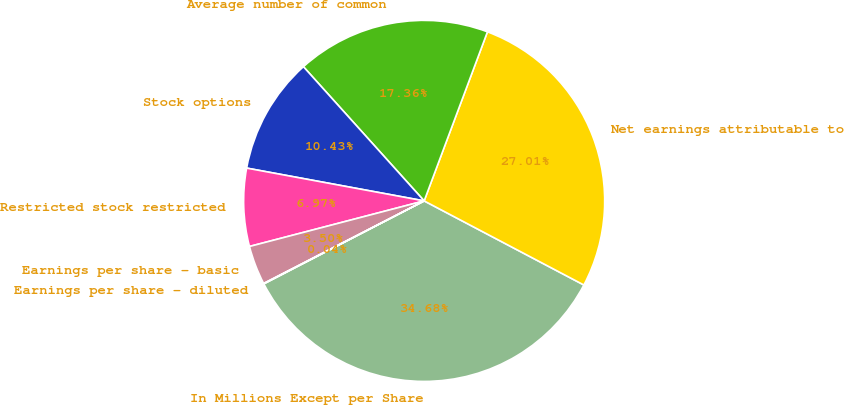Convert chart to OTSL. <chart><loc_0><loc_0><loc_500><loc_500><pie_chart><fcel>In Millions Except per Share<fcel>Net earnings attributable to<fcel>Average number of common<fcel>Stock options<fcel>Restricted stock restricted<fcel>Earnings per share - basic<fcel>Earnings per share - diluted<nl><fcel>34.68%<fcel>27.01%<fcel>17.36%<fcel>10.43%<fcel>6.97%<fcel>3.5%<fcel>0.04%<nl></chart> 